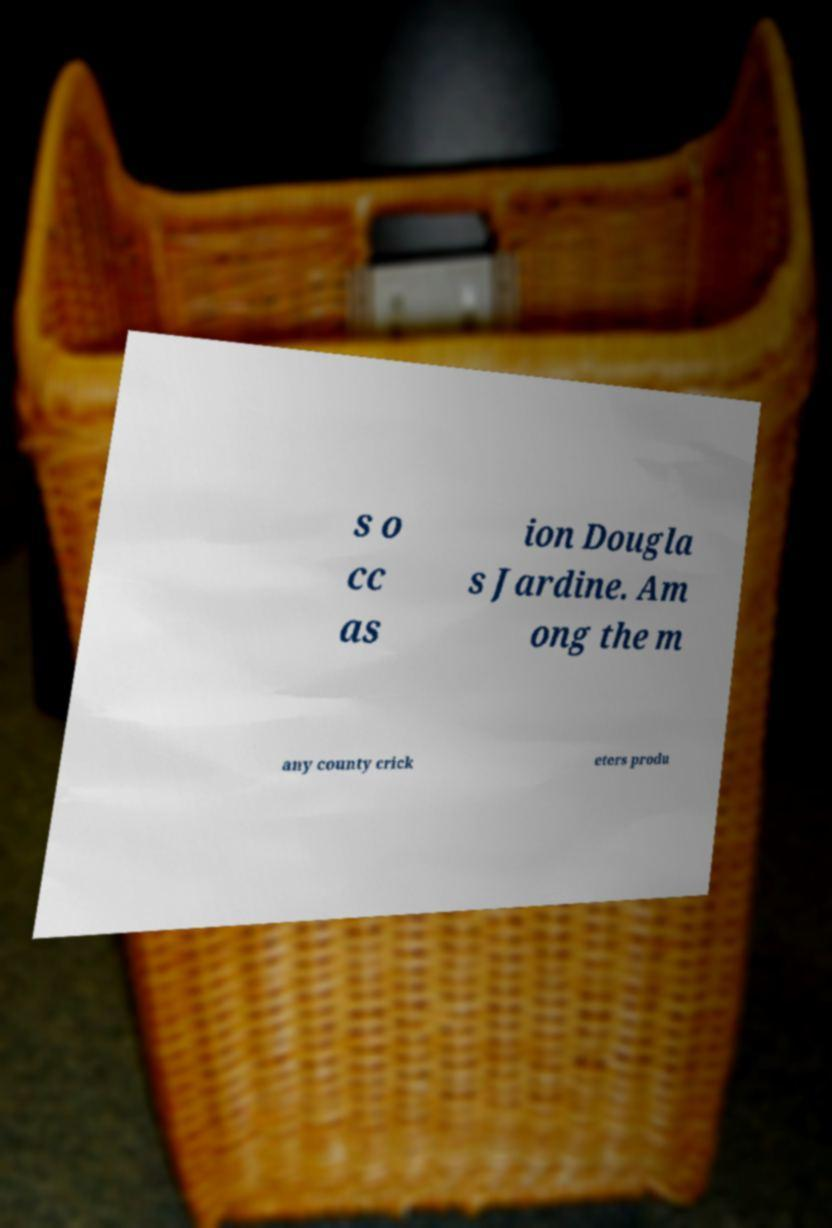Please identify and transcribe the text found in this image. s o cc as ion Dougla s Jardine. Am ong the m any county crick eters produ 